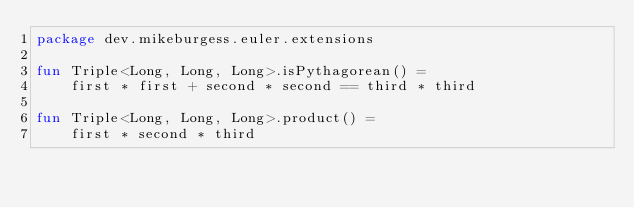Convert code to text. <code><loc_0><loc_0><loc_500><loc_500><_Kotlin_>package dev.mikeburgess.euler.extensions

fun Triple<Long, Long, Long>.isPythagorean() =
    first * first + second * second == third * third

fun Triple<Long, Long, Long>.product() =
    first * second * third
</code> 